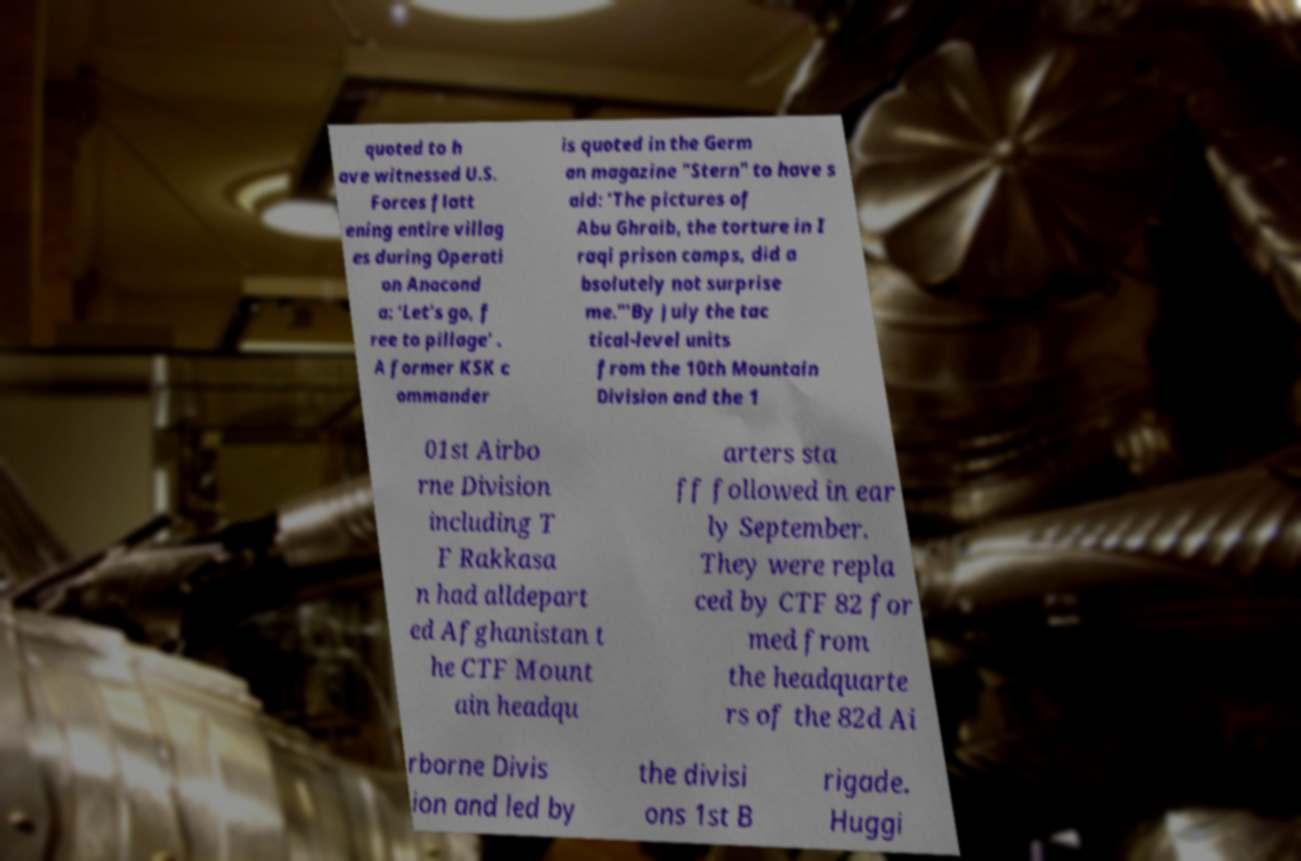Can you read and provide the text displayed in the image?This photo seems to have some interesting text. Can you extract and type it out for me? quoted to h ave witnessed U.S. Forces flatt ening entire villag es during Operati on Anacond a: 'Let's go, f ree to pillage' . A former KSK c ommander is quoted in the Germ an magazine "Stern" to have s aid: 'The pictures of Abu Ghraib, the torture in I raqi prison camps, did a bsolutely not surprise me."'By July the tac tical-level units from the 10th Mountain Division and the 1 01st Airbo rne Division including T F Rakkasa n had alldepart ed Afghanistan t he CTF Mount ain headqu arters sta ff followed in ear ly September. They were repla ced by CTF 82 for med from the headquarte rs of the 82d Ai rborne Divis ion and led by the divisi ons 1st B rigade. Huggi 